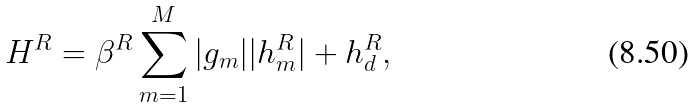<formula> <loc_0><loc_0><loc_500><loc_500>H ^ { R } = \beta ^ { R } \sum _ { m = 1 } ^ { M } | g _ { m } | | h ^ { R } _ { m } | + h ^ { R } _ { d } ,</formula> 